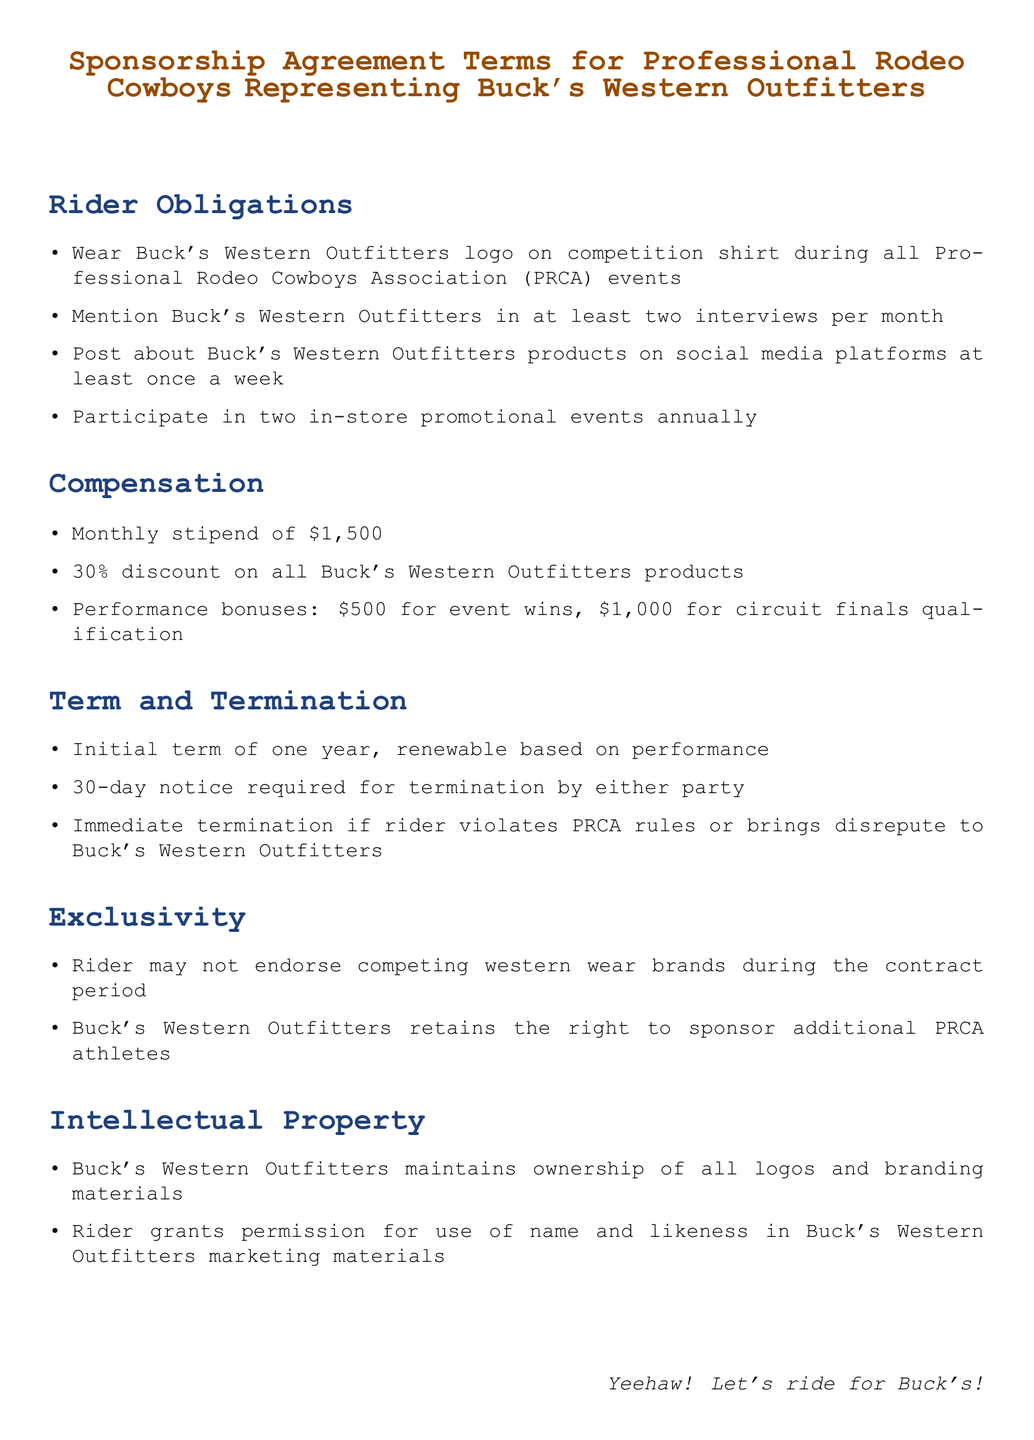What logo must the rider wear? The rider must wear Buck's Western Outfitters logo on their competition shirt.
Answer: Buck's Western Outfitters logo What is the monthly stipend amount? The monthly stipend is mentioned in the compensation section, which states it is \$1,500.
Answer: \$1,500 How many promotional events must the rider participate in annually? The document specifies that the rider must participate in two in-store promotional events annually.
Answer: two What is the initial term of the sponsorship? The initial term of the sponsorship agreement is stated as one year.
Answer: one year What percentage discount do riders receive on products? The compensation section mentions that riders receive a 30% discount on all Buck's Western Outfitters products.
Answer: 30% What happens if the rider violates PRCA rules? The document states that immediate termination can happen if the rider violates PRCA rules.
Answer: Immediate termination Can the rider endorse competing brands during the contract? The exclusivity section specifies that the rider may not endorse competing western wear brands during the contract period.
Answer: No What permission does the rider grant regarding their name and likeness? The rider grants permission for the use of their name and likeness in Buck's Western Outfitters marketing materials.
Answer: Use of name and likeness What is the bonus for winning an event? The performance bonuses section specifies that the bonus for event wins is \$500.
Answer: \$500 